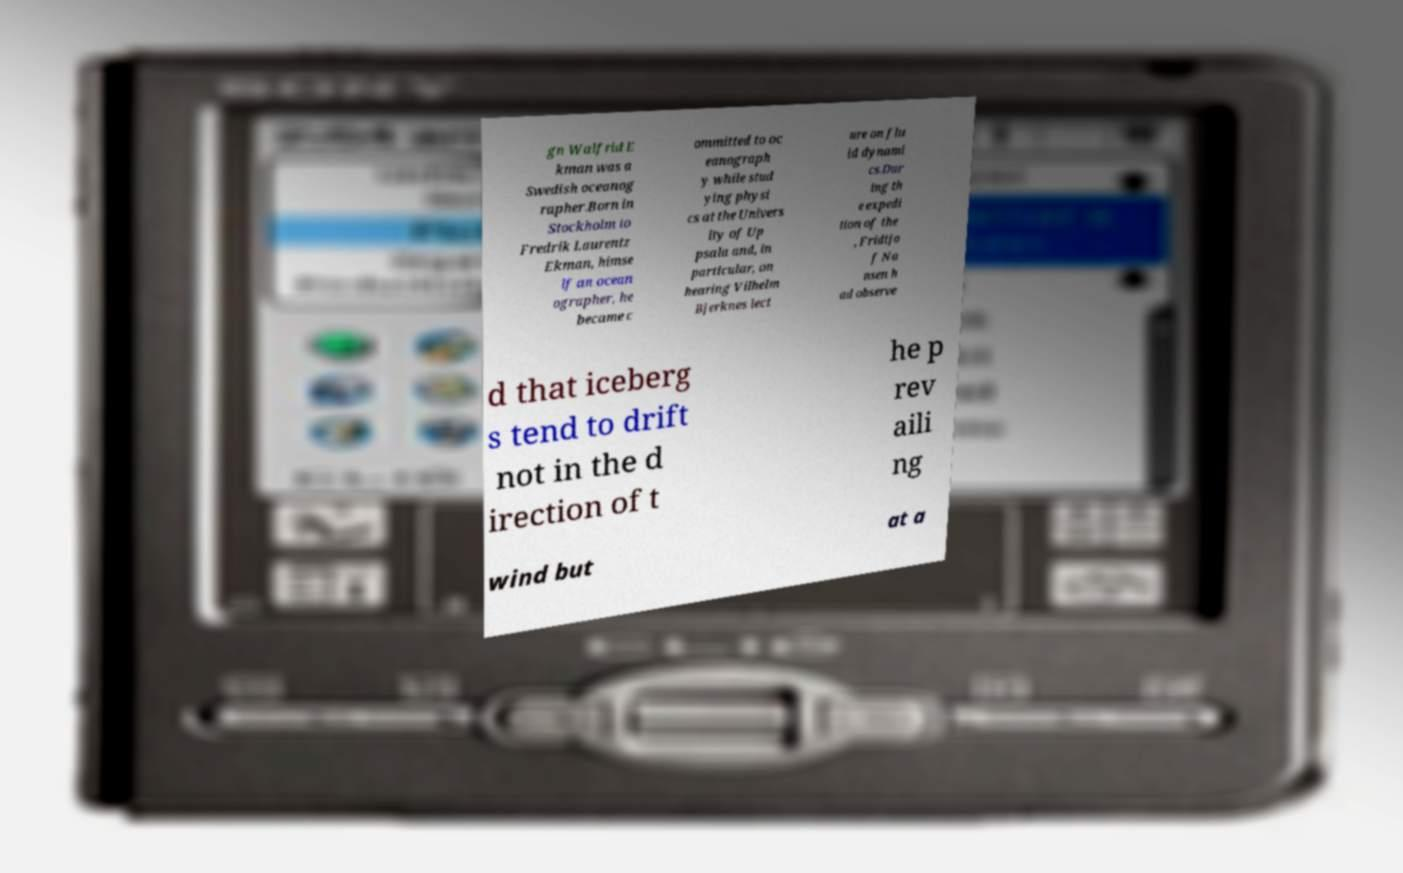What messages or text are displayed in this image? I need them in a readable, typed format. gn Walfrid E kman was a Swedish oceanog rapher.Born in Stockholm to Fredrik Laurentz Ekman, himse lf an ocean ographer, he became c ommitted to oc eanograph y while stud ying physi cs at the Univers ity of Up psala and, in particular, on hearing Vilhelm Bjerknes lect ure on flu id dynami cs.Dur ing th e expedi tion of the , Fridtjo f Na nsen h ad observe d that iceberg s tend to drift not in the d irection of t he p rev aili ng wind but at a 